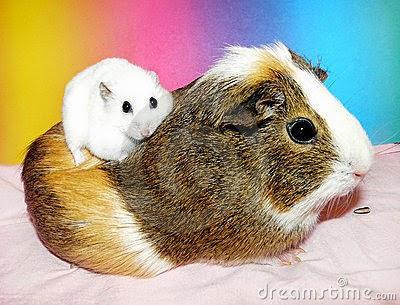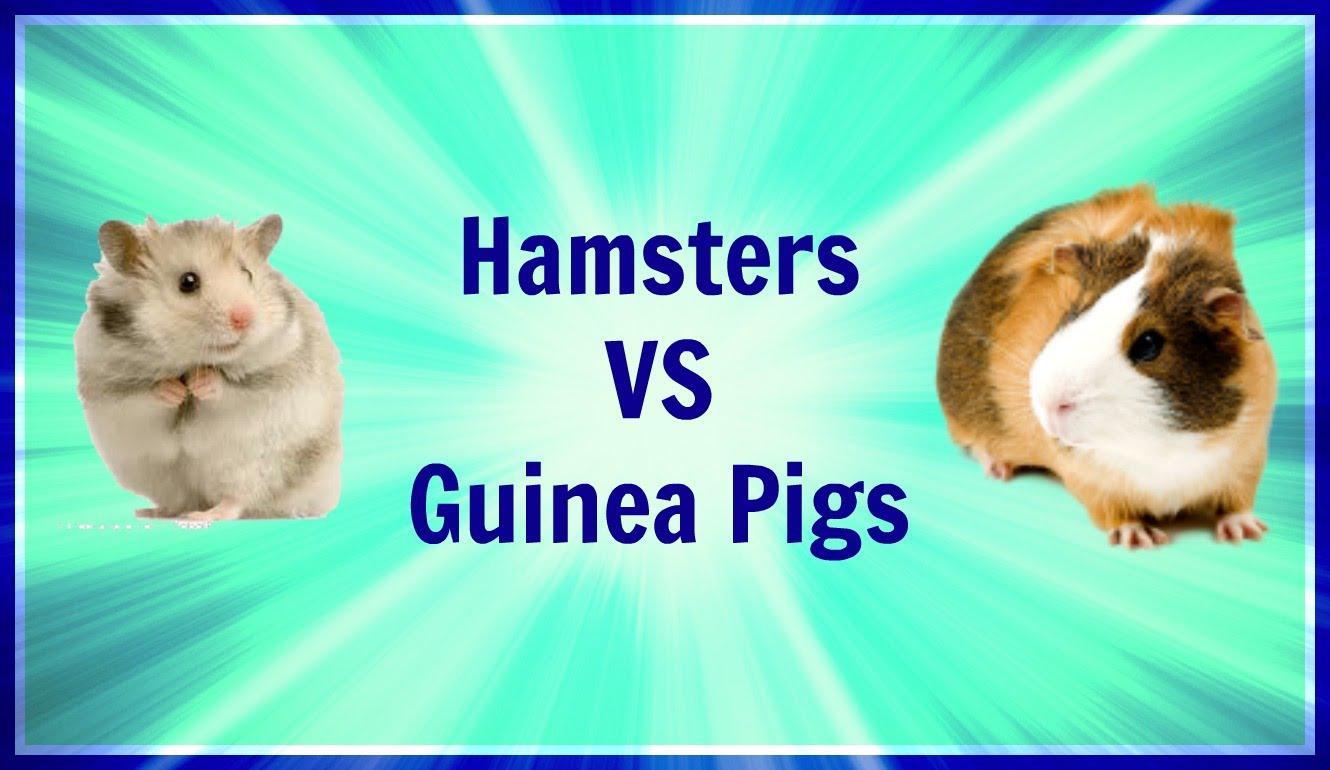The first image is the image on the left, the second image is the image on the right. Evaluate the accuracy of this statement regarding the images: "An image shows a larger guinea pig with a smaller pet rodent on a fabric ground surface.". Is it true? Answer yes or no. Yes. The first image is the image on the left, the second image is the image on the right. Evaluate the accuracy of this statement regarding the images: "The rodents in the image on the left are sitting on green grass.". Is it true? Answer yes or no. No. 